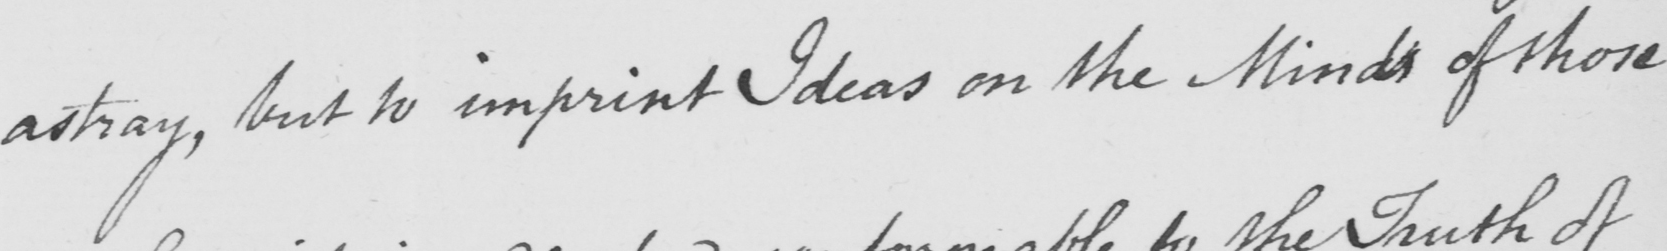What is written in this line of handwriting? astray , but to imprint Ideas on the Minds of those 